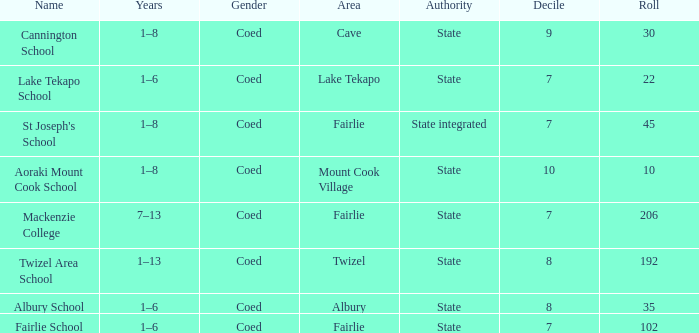What is the cumulative decile of a state authority in the fairlie area with a roll exceeding 206? 1.0. 